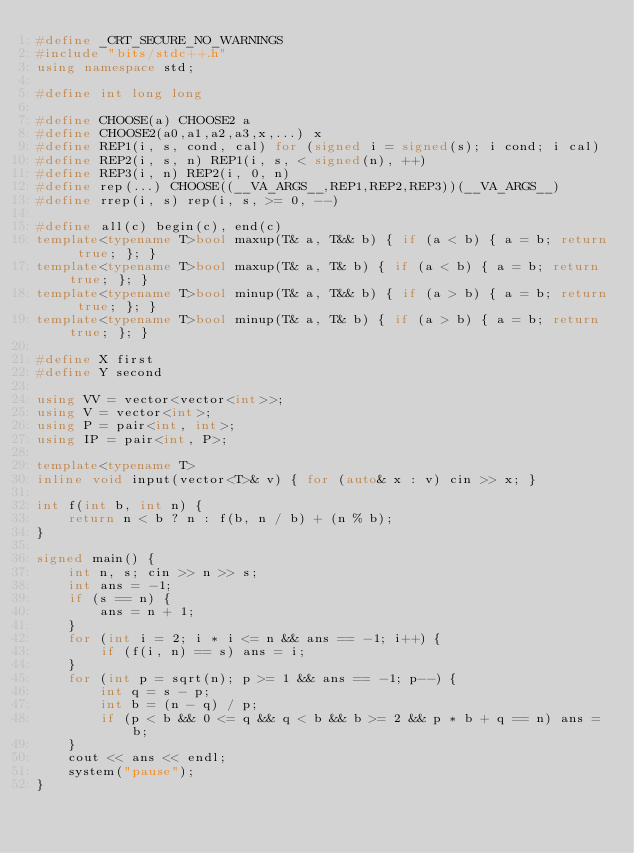Convert code to text. <code><loc_0><loc_0><loc_500><loc_500><_C++_>#define _CRT_SECURE_NO_WARNINGS
#include "bits/stdc++.h"
using namespace std;

#define int long long

#define CHOOSE(a) CHOOSE2 a
#define CHOOSE2(a0,a1,a2,a3,x,...) x
#define REP1(i, s, cond, cal) for (signed i = signed(s); i cond; i cal)
#define REP2(i, s, n) REP1(i, s, < signed(n), ++)
#define REP3(i, n) REP2(i, 0, n)
#define rep(...) CHOOSE((__VA_ARGS__,REP1,REP2,REP3))(__VA_ARGS__)
#define rrep(i, s) rep(i, s, >= 0, --)

#define all(c) begin(c), end(c)
template<typename T>bool maxup(T& a, T&& b) { if (a < b) { a = b; return true; }; }
template<typename T>bool maxup(T& a, T& b) { if (a < b) { a = b; return true; }; }
template<typename T>bool minup(T& a, T&& b) { if (a > b) { a = b; return true; }; }
template<typename T>bool minup(T& a, T& b) { if (a > b) { a = b; return true; }; }

#define X first
#define Y second

using VV = vector<vector<int>>;
using V = vector<int>;
using P = pair<int, int>;
using IP = pair<int, P>;

template<typename T>
inline void input(vector<T>& v) { for (auto& x : v) cin >> x; }

int f(int b, int n) {
	return n < b ? n : f(b, n / b) + (n % b);
}

signed main() {
	int n, s; cin >> n >> s;
	int ans = -1;
	if (s == n) {
		ans = n + 1;
	}
	for (int i = 2; i * i <= n && ans == -1; i++) {
		if (f(i, n) == s) ans = i;
	}
	for (int p = sqrt(n); p >= 1 && ans == -1; p--) {
		int q = s - p;
		int b = (n - q) / p;
		if (p < b && 0 <= q && q < b && b >= 2 && p * b + q == n) ans = b;
	}
	cout << ans << endl;
	system("pause");
}</code> 